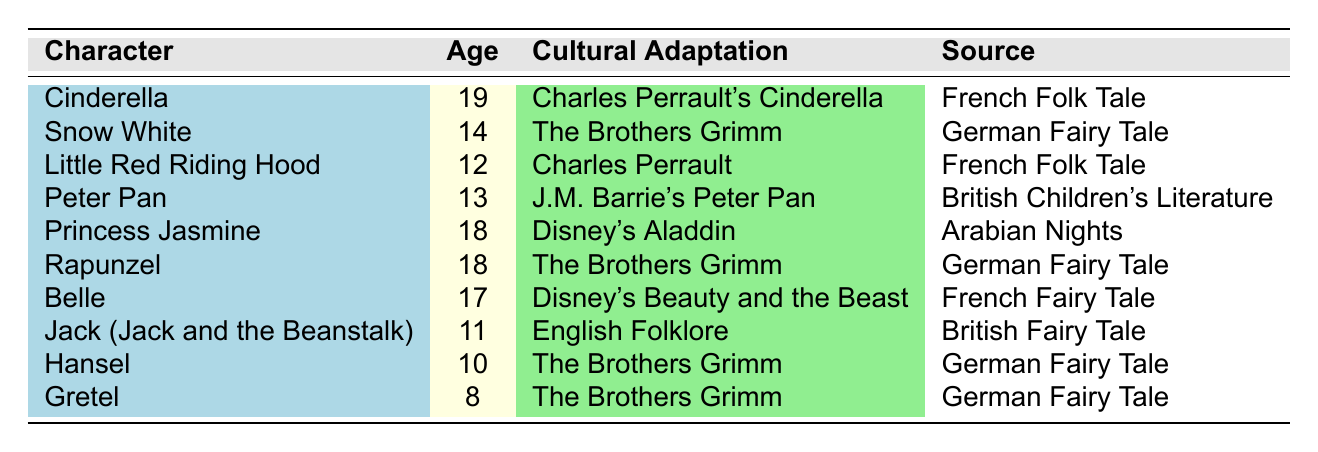What is the age of Cinderella in the table? The table lists Cinderella with an age value of 19 years.
Answer: 19 Which character is the youngest in the table? The ages of the characters are Gretel (8), Hansel (10), Jack (11), Little Red Riding Hood (12), Peter Pan (13), Snow White (14), and others. The youngest character is Gretel at age 8.
Answer: Gretel How many characters are 18 years old in the table? The characters at age 18 are Princess Jasmine and Rapunzel. Counting them gives a total of 2 characters.
Answer: 2 What is the average age of Peter Pan and Little Red Riding Hood? Peter Pan is 13 and Little Red Riding Hood is 12, so their average age is calculated as (13 + 12) / 2 = 25 / 2 = 12.5.
Answer: 12.5 Is Snow White older than Belle according to the table? Snow White is listed as 14 years old and Belle as 17 years old. Since 17 is greater than 14, the statement is false.
Answer: No Which cultural adaptation has the oldest character? The table shows Cinderella as 19 years old in Charles Perrault's Cinderella. Since no other character is older, Cinderella has the oldest character at 19.
Answer: Charles Perrault's Cinderella How many characters are from German fairy tales? The characters listed from German fairy tales are Snow White, Rapunzel, Hansel, and Gretel, totaling 4 characters.
Answer: 4 Which character has the highest age difference from the average age of all characters listed? First, we find the average age of all characters: (19 + 14 + 12 + 13 + 18 + 18 + 17 + 11 + 10 + 8) / 10 = 14.8. Then, comparing this average to each character's age, Cinderella (19) has the highest age difference of 4.2 years.
Answer: Cinderella How many characters have ages less than 15? The characters under 15 are Little Red Riding Hood (12), Peter Pan (13), Jack (11), Hansel (10), and Gretel (8), totaling 5 characters.
Answer: 5 